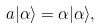<formula> <loc_0><loc_0><loc_500><loc_500>a | \alpha \rangle = \alpha | \alpha \rangle ,</formula> 